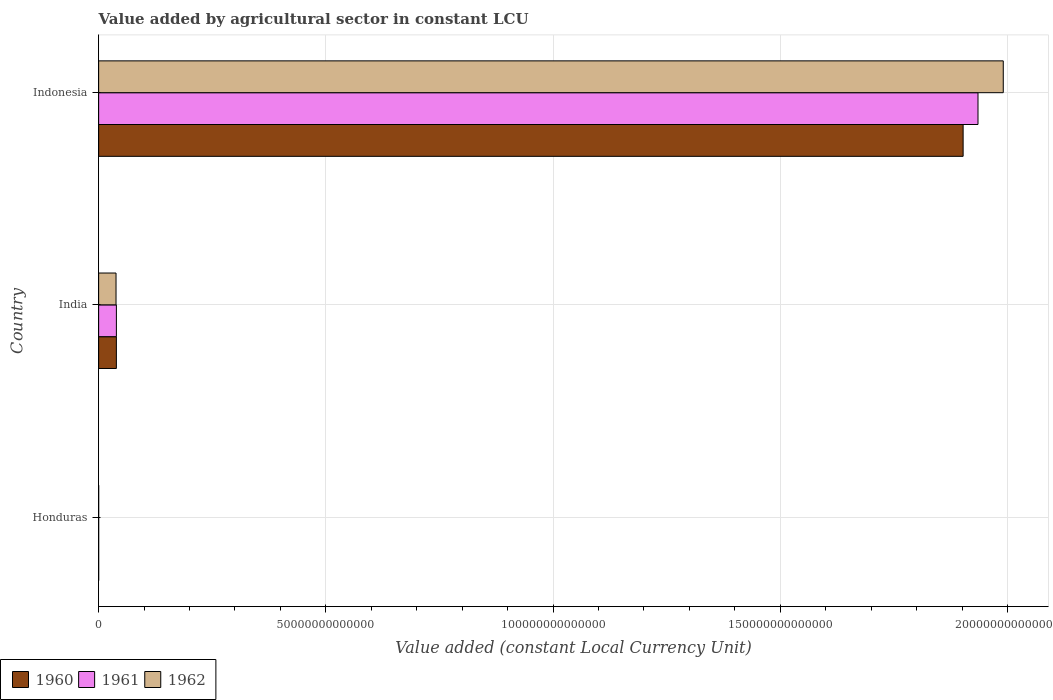Are the number of bars per tick equal to the number of legend labels?
Ensure brevity in your answer.  Yes. Are the number of bars on each tick of the Y-axis equal?
Offer a very short reply. Yes. How many bars are there on the 1st tick from the top?
Keep it short and to the point. 3. What is the label of the 3rd group of bars from the top?
Provide a succinct answer. Honduras. In how many cases, is the number of bars for a given country not equal to the number of legend labels?
Ensure brevity in your answer.  0. What is the value added by agricultural sector in 1960 in India?
Make the answer very short. 3.90e+12. Across all countries, what is the maximum value added by agricultural sector in 1960?
Make the answer very short. 1.90e+14. Across all countries, what is the minimum value added by agricultural sector in 1961?
Give a very brief answer. 4.73e+09. In which country was the value added by agricultural sector in 1961 minimum?
Your answer should be very brief. Honduras. What is the total value added by agricultural sector in 1961 in the graph?
Offer a terse response. 1.97e+14. What is the difference between the value added by agricultural sector in 1960 in India and that in Indonesia?
Ensure brevity in your answer.  -1.86e+14. What is the difference between the value added by agricultural sector in 1960 in Honduras and the value added by agricultural sector in 1961 in Indonesia?
Keep it short and to the point. -1.94e+14. What is the average value added by agricultural sector in 1962 per country?
Your response must be concise. 6.76e+13. What is the difference between the value added by agricultural sector in 1960 and value added by agricultural sector in 1962 in Honduras?
Your answer should be very brief. -5.15e+08. In how many countries, is the value added by agricultural sector in 1962 greater than 60000000000000 LCU?
Keep it short and to the point. 1. What is the ratio of the value added by agricultural sector in 1962 in Honduras to that in India?
Your answer should be compact. 0. Is the difference between the value added by agricultural sector in 1960 in Honduras and India greater than the difference between the value added by agricultural sector in 1962 in Honduras and India?
Make the answer very short. No. What is the difference between the highest and the second highest value added by agricultural sector in 1960?
Your answer should be very brief. 1.86e+14. What is the difference between the highest and the lowest value added by agricultural sector in 1962?
Offer a terse response. 1.99e+14. In how many countries, is the value added by agricultural sector in 1962 greater than the average value added by agricultural sector in 1962 taken over all countries?
Provide a succinct answer. 1. What does the 3rd bar from the top in Honduras represents?
Keep it short and to the point. 1960. What does the 2nd bar from the bottom in Indonesia represents?
Your answer should be very brief. 1961. Is it the case that in every country, the sum of the value added by agricultural sector in 1961 and value added by agricultural sector in 1962 is greater than the value added by agricultural sector in 1960?
Offer a very short reply. Yes. How many bars are there?
Your response must be concise. 9. How many countries are there in the graph?
Keep it short and to the point. 3. What is the difference between two consecutive major ticks on the X-axis?
Your response must be concise. 5.00e+13. Are the values on the major ticks of X-axis written in scientific E-notation?
Provide a short and direct response. No. Does the graph contain any zero values?
Give a very brief answer. No. Does the graph contain grids?
Your answer should be very brief. Yes. What is the title of the graph?
Offer a terse response. Value added by agricultural sector in constant LCU. Does "1966" appear as one of the legend labels in the graph?
Ensure brevity in your answer.  No. What is the label or title of the X-axis?
Offer a very short reply. Value added (constant Local Currency Unit). What is the Value added (constant Local Currency Unit) in 1960 in Honduras?
Provide a short and direct response. 4.44e+09. What is the Value added (constant Local Currency Unit) of 1961 in Honduras?
Your answer should be very brief. 4.73e+09. What is the Value added (constant Local Currency Unit) in 1962 in Honduras?
Your answer should be very brief. 4.96e+09. What is the Value added (constant Local Currency Unit) in 1960 in India?
Offer a terse response. 3.90e+12. What is the Value added (constant Local Currency Unit) in 1961 in India?
Provide a succinct answer. 3.91e+12. What is the Value added (constant Local Currency Unit) in 1962 in India?
Offer a very short reply. 3.83e+12. What is the Value added (constant Local Currency Unit) of 1960 in Indonesia?
Ensure brevity in your answer.  1.90e+14. What is the Value added (constant Local Currency Unit) in 1961 in Indonesia?
Your answer should be very brief. 1.94e+14. What is the Value added (constant Local Currency Unit) in 1962 in Indonesia?
Offer a terse response. 1.99e+14. Across all countries, what is the maximum Value added (constant Local Currency Unit) of 1960?
Offer a very short reply. 1.90e+14. Across all countries, what is the maximum Value added (constant Local Currency Unit) of 1961?
Make the answer very short. 1.94e+14. Across all countries, what is the maximum Value added (constant Local Currency Unit) of 1962?
Offer a very short reply. 1.99e+14. Across all countries, what is the minimum Value added (constant Local Currency Unit) in 1960?
Your answer should be very brief. 4.44e+09. Across all countries, what is the minimum Value added (constant Local Currency Unit) of 1961?
Your answer should be compact. 4.73e+09. Across all countries, what is the minimum Value added (constant Local Currency Unit) of 1962?
Your answer should be compact. 4.96e+09. What is the total Value added (constant Local Currency Unit) in 1960 in the graph?
Ensure brevity in your answer.  1.94e+14. What is the total Value added (constant Local Currency Unit) of 1961 in the graph?
Your response must be concise. 1.97e+14. What is the total Value added (constant Local Currency Unit) of 1962 in the graph?
Keep it short and to the point. 2.03e+14. What is the difference between the Value added (constant Local Currency Unit) in 1960 in Honduras and that in India?
Offer a terse response. -3.90e+12. What is the difference between the Value added (constant Local Currency Unit) in 1961 in Honduras and that in India?
Give a very brief answer. -3.90e+12. What is the difference between the Value added (constant Local Currency Unit) in 1962 in Honduras and that in India?
Offer a very short reply. -3.82e+12. What is the difference between the Value added (constant Local Currency Unit) of 1960 in Honduras and that in Indonesia?
Keep it short and to the point. -1.90e+14. What is the difference between the Value added (constant Local Currency Unit) of 1961 in Honduras and that in Indonesia?
Offer a very short reply. -1.94e+14. What is the difference between the Value added (constant Local Currency Unit) of 1962 in Honduras and that in Indonesia?
Your answer should be compact. -1.99e+14. What is the difference between the Value added (constant Local Currency Unit) in 1960 in India and that in Indonesia?
Provide a succinct answer. -1.86e+14. What is the difference between the Value added (constant Local Currency Unit) of 1961 in India and that in Indonesia?
Give a very brief answer. -1.90e+14. What is the difference between the Value added (constant Local Currency Unit) in 1962 in India and that in Indonesia?
Provide a short and direct response. -1.95e+14. What is the difference between the Value added (constant Local Currency Unit) of 1960 in Honduras and the Value added (constant Local Currency Unit) of 1961 in India?
Ensure brevity in your answer.  -3.90e+12. What is the difference between the Value added (constant Local Currency Unit) in 1960 in Honduras and the Value added (constant Local Currency Unit) in 1962 in India?
Offer a terse response. -3.83e+12. What is the difference between the Value added (constant Local Currency Unit) in 1961 in Honduras and the Value added (constant Local Currency Unit) in 1962 in India?
Keep it short and to the point. -3.83e+12. What is the difference between the Value added (constant Local Currency Unit) of 1960 in Honduras and the Value added (constant Local Currency Unit) of 1961 in Indonesia?
Your answer should be very brief. -1.94e+14. What is the difference between the Value added (constant Local Currency Unit) of 1960 in Honduras and the Value added (constant Local Currency Unit) of 1962 in Indonesia?
Your response must be concise. -1.99e+14. What is the difference between the Value added (constant Local Currency Unit) in 1961 in Honduras and the Value added (constant Local Currency Unit) in 1962 in Indonesia?
Your answer should be compact. -1.99e+14. What is the difference between the Value added (constant Local Currency Unit) in 1960 in India and the Value added (constant Local Currency Unit) in 1961 in Indonesia?
Your response must be concise. -1.90e+14. What is the difference between the Value added (constant Local Currency Unit) in 1960 in India and the Value added (constant Local Currency Unit) in 1962 in Indonesia?
Your answer should be compact. -1.95e+14. What is the difference between the Value added (constant Local Currency Unit) of 1961 in India and the Value added (constant Local Currency Unit) of 1962 in Indonesia?
Your answer should be compact. -1.95e+14. What is the average Value added (constant Local Currency Unit) in 1960 per country?
Give a very brief answer. 6.47e+13. What is the average Value added (constant Local Currency Unit) of 1961 per country?
Give a very brief answer. 6.58e+13. What is the average Value added (constant Local Currency Unit) in 1962 per country?
Provide a short and direct response. 6.76e+13. What is the difference between the Value added (constant Local Currency Unit) of 1960 and Value added (constant Local Currency Unit) of 1961 in Honduras?
Offer a very short reply. -2.90e+08. What is the difference between the Value added (constant Local Currency Unit) in 1960 and Value added (constant Local Currency Unit) in 1962 in Honduras?
Make the answer very short. -5.15e+08. What is the difference between the Value added (constant Local Currency Unit) of 1961 and Value added (constant Local Currency Unit) of 1962 in Honduras?
Offer a terse response. -2.25e+08. What is the difference between the Value added (constant Local Currency Unit) of 1960 and Value added (constant Local Currency Unit) of 1961 in India?
Provide a succinct answer. -3.29e+09. What is the difference between the Value added (constant Local Currency Unit) in 1960 and Value added (constant Local Currency Unit) in 1962 in India?
Your answer should be very brief. 7.44e+1. What is the difference between the Value added (constant Local Currency Unit) in 1961 and Value added (constant Local Currency Unit) in 1962 in India?
Your response must be concise. 7.77e+1. What is the difference between the Value added (constant Local Currency Unit) in 1960 and Value added (constant Local Currency Unit) in 1961 in Indonesia?
Give a very brief answer. -3.27e+12. What is the difference between the Value added (constant Local Currency Unit) in 1960 and Value added (constant Local Currency Unit) in 1962 in Indonesia?
Your answer should be very brief. -8.83e+12. What is the difference between the Value added (constant Local Currency Unit) of 1961 and Value added (constant Local Currency Unit) of 1962 in Indonesia?
Your response must be concise. -5.56e+12. What is the ratio of the Value added (constant Local Currency Unit) of 1960 in Honduras to that in India?
Provide a succinct answer. 0. What is the ratio of the Value added (constant Local Currency Unit) in 1961 in Honduras to that in India?
Your response must be concise. 0. What is the ratio of the Value added (constant Local Currency Unit) of 1962 in Honduras to that in India?
Ensure brevity in your answer.  0. What is the ratio of the Value added (constant Local Currency Unit) of 1960 in Honduras to that in Indonesia?
Provide a short and direct response. 0. What is the ratio of the Value added (constant Local Currency Unit) of 1960 in India to that in Indonesia?
Your answer should be compact. 0.02. What is the ratio of the Value added (constant Local Currency Unit) of 1961 in India to that in Indonesia?
Make the answer very short. 0.02. What is the ratio of the Value added (constant Local Currency Unit) of 1962 in India to that in Indonesia?
Your response must be concise. 0.02. What is the difference between the highest and the second highest Value added (constant Local Currency Unit) of 1960?
Your response must be concise. 1.86e+14. What is the difference between the highest and the second highest Value added (constant Local Currency Unit) of 1961?
Your response must be concise. 1.90e+14. What is the difference between the highest and the second highest Value added (constant Local Currency Unit) of 1962?
Offer a terse response. 1.95e+14. What is the difference between the highest and the lowest Value added (constant Local Currency Unit) of 1960?
Provide a succinct answer. 1.90e+14. What is the difference between the highest and the lowest Value added (constant Local Currency Unit) in 1961?
Your response must be concise. 1.94e+14. What is the difference between the highest and the lowest Value added (constant Local Currency Unit) in 1962?
Offer a very short reply. 1.99e+14. 